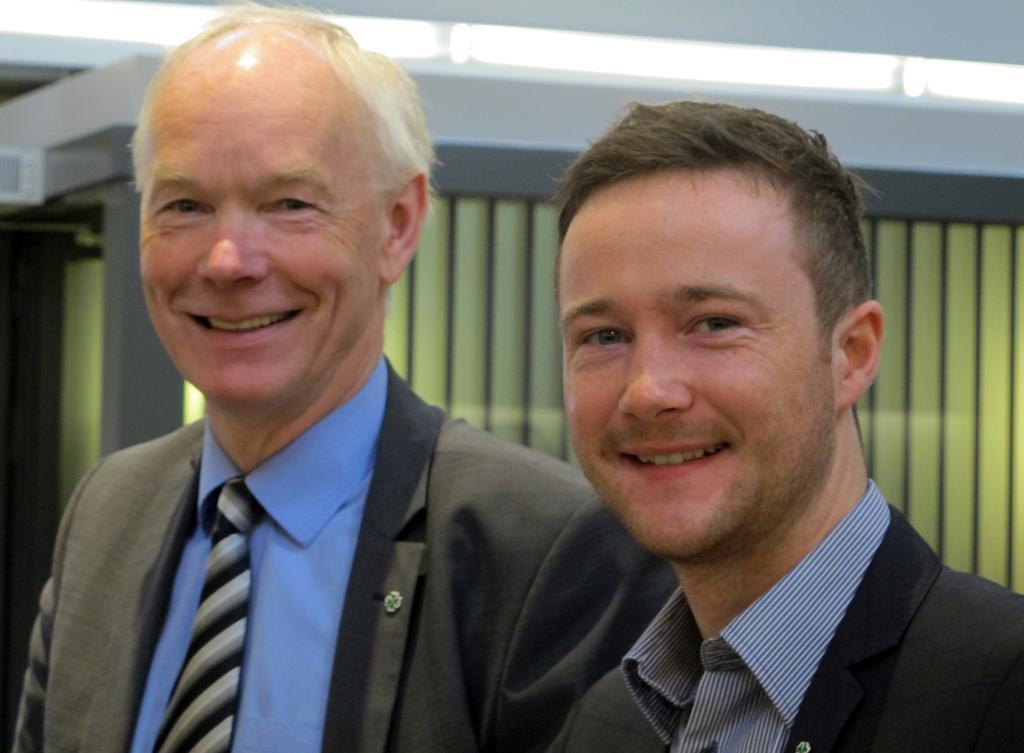Describe this image in one or two sentences. In the center of the image we can see two people standing and smiling. They are wearing suits. In the background we can see a wall and lights. 